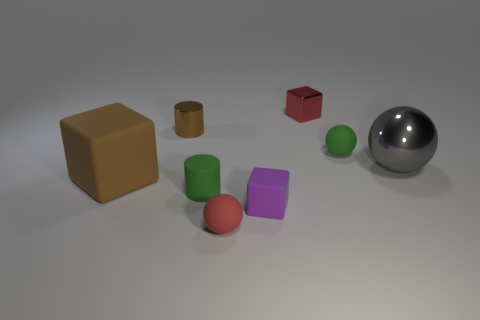Add 1 tiny brown cylinders. How many objects exist? 9 Subtract all spheres. How many objects are left? 5 Subtract 1 red cubes. How many objects are left? 7 Subtract all metal blocks. Subtract all tiny brown metal things. How many objects are left? 6 Add 3 purple cubes. How many purple cubes are left? 4 Add 1 purple matte blocks. How many purple matte blocks exist? 2 